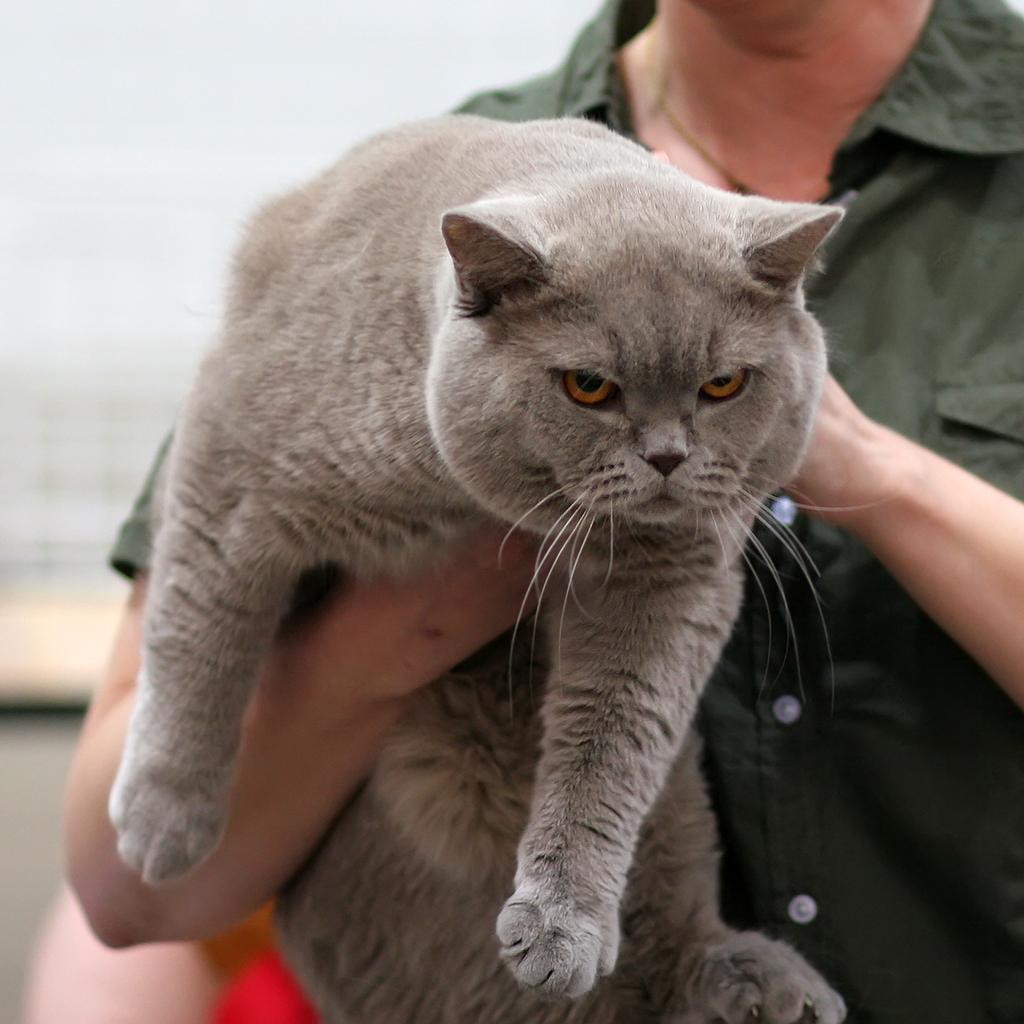What is the main subject of the image? There is a person in the image. What is the person doing in the image? The person is holding a cat with his hands. What is the topic of the discussion between the person and the cat in the image? There is no discussion between the person and the cat in the image, as the cat is being held by the person. How does the cat exchange its paws while being held by the person in the image? The cat is not shown exchanging its paws in the image; it is being held by the person. 